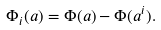<formula> <loc_0><loc_0><loc_500><loc_500>\Phi _ { i } ( a ) = \Phi ( a ) - \Phi ( a ^ { i } ) .</formula> 